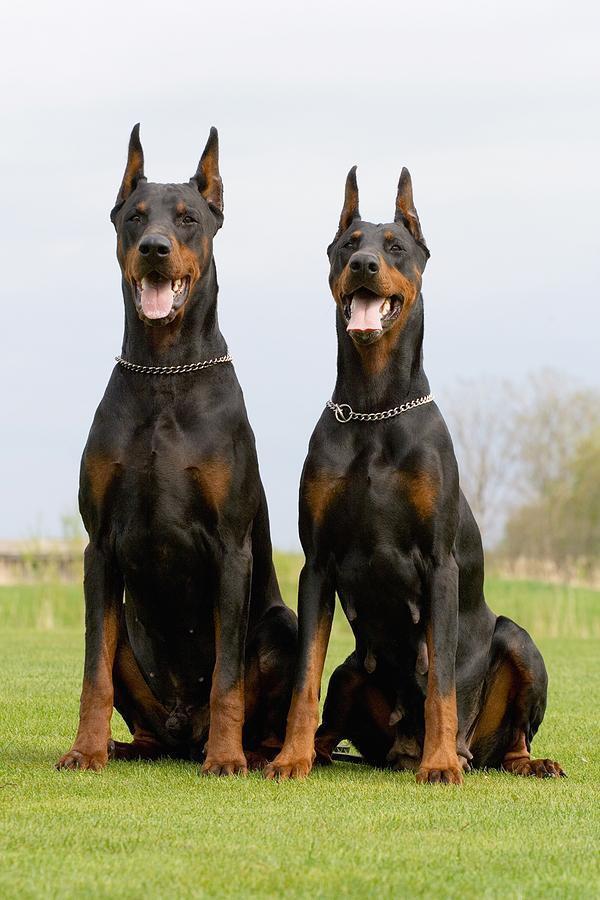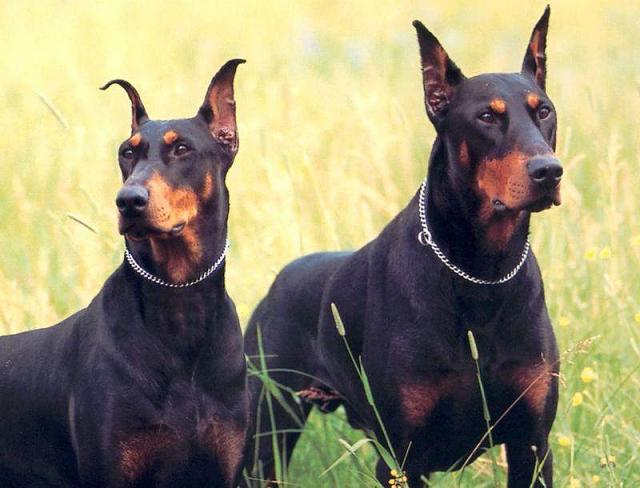The first image is the image on the left, the second image is the image on the right. Given the left and right images, does the statement "A single dog in the grass is showing its tongue in the image on the left." hold true? Answer yes or no. No. The first image is the image on the left, the second image is the image on the right. Evaluate the accuracy of this statement regarding the images: "Each image contains one dog, and one of the dogs depicted wears a chain collar, while the other dog has something held in its mouth.". Is it true? Answer yes or no. No. 